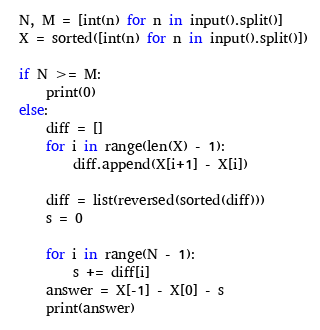Convert code to text. <code><loc_0><loc_0><loc_500><loc_500><_Python_> N, M = [int(n) for n in input().split()]
 X = sorted([int(n) for n in input().split()])

 if N >= M:
     print(0)
 else:
     diff = []
     for i in range(len(X) - 1):
         diff.append(X[i+1] - X[i])

     diff = list(reversed(sorted(diff)))
     s = 0

     for i in range(N - 1):
         s += diff[i]
     answer = X[-1] - X[0] - s
     print(answer)</code> 